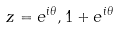Convert formula to latex. <formula><loc_0><loc_0><loc_500><loc_500>z = e ^ { i \theta } , 1 + e ^ { i \theta }</formula> 